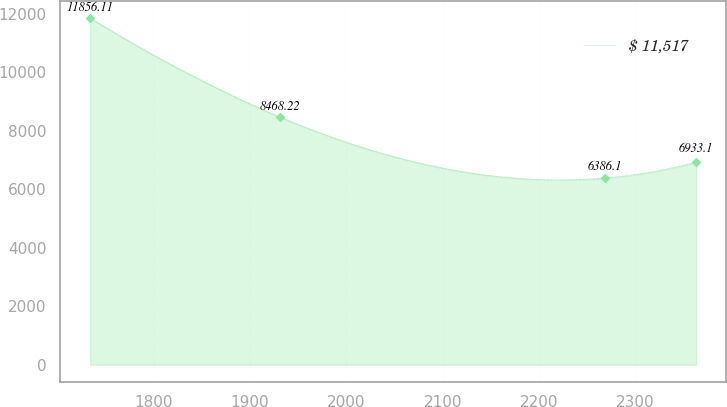Convert chart. <chart><loc_0><loc_0><loc_500><loc_500><line_chart><ecel><fcel>$ 11,517<nl><fcel>1733.86<fcel>11856.1<nl><fcel>1931.47<fcel>8468.22<nl><fcel>2268.25<fcel>6386.1<nl><fcel>2363.31<fcel>6933.1<nl></chart> 